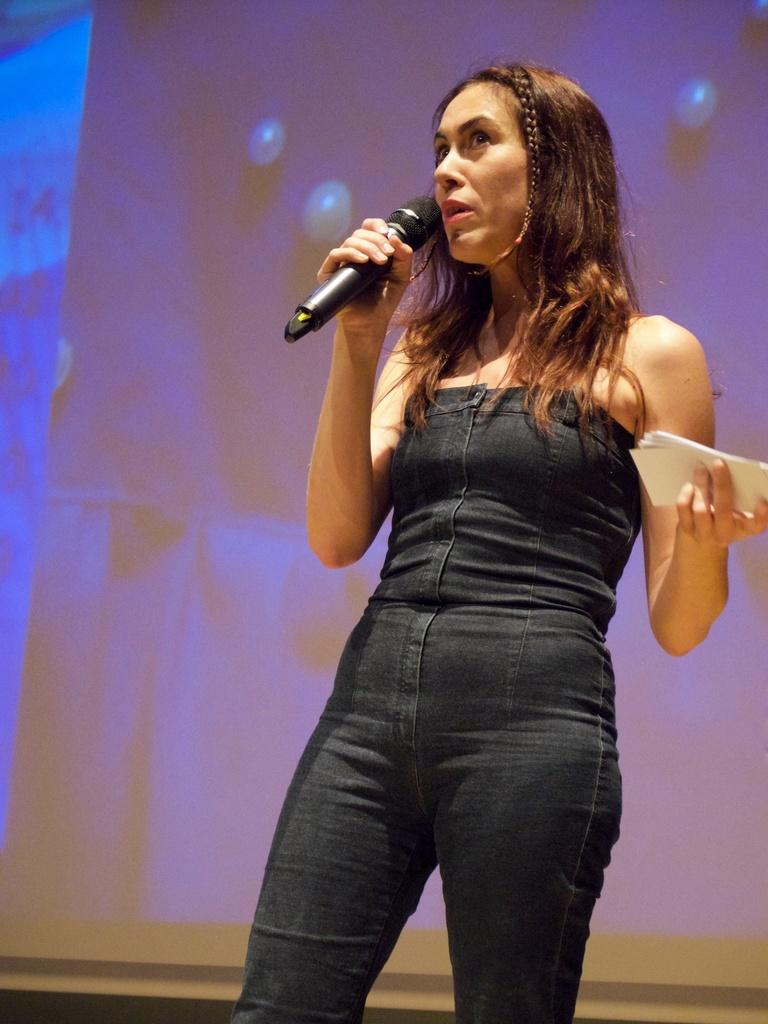Who is the main subject in the image? There is a woman in the image. What is the woman doing in the image? The woman is standing in the image. What objects is the woman holding in the image? The woman is holding a microphone and some papers in the image. How many children are visible in the image? There are no children visible in the image; it features a woman holding a microphone and some papers. What type of paint is being used by the woman in the image? There is no paint or painting activity present in the image. 